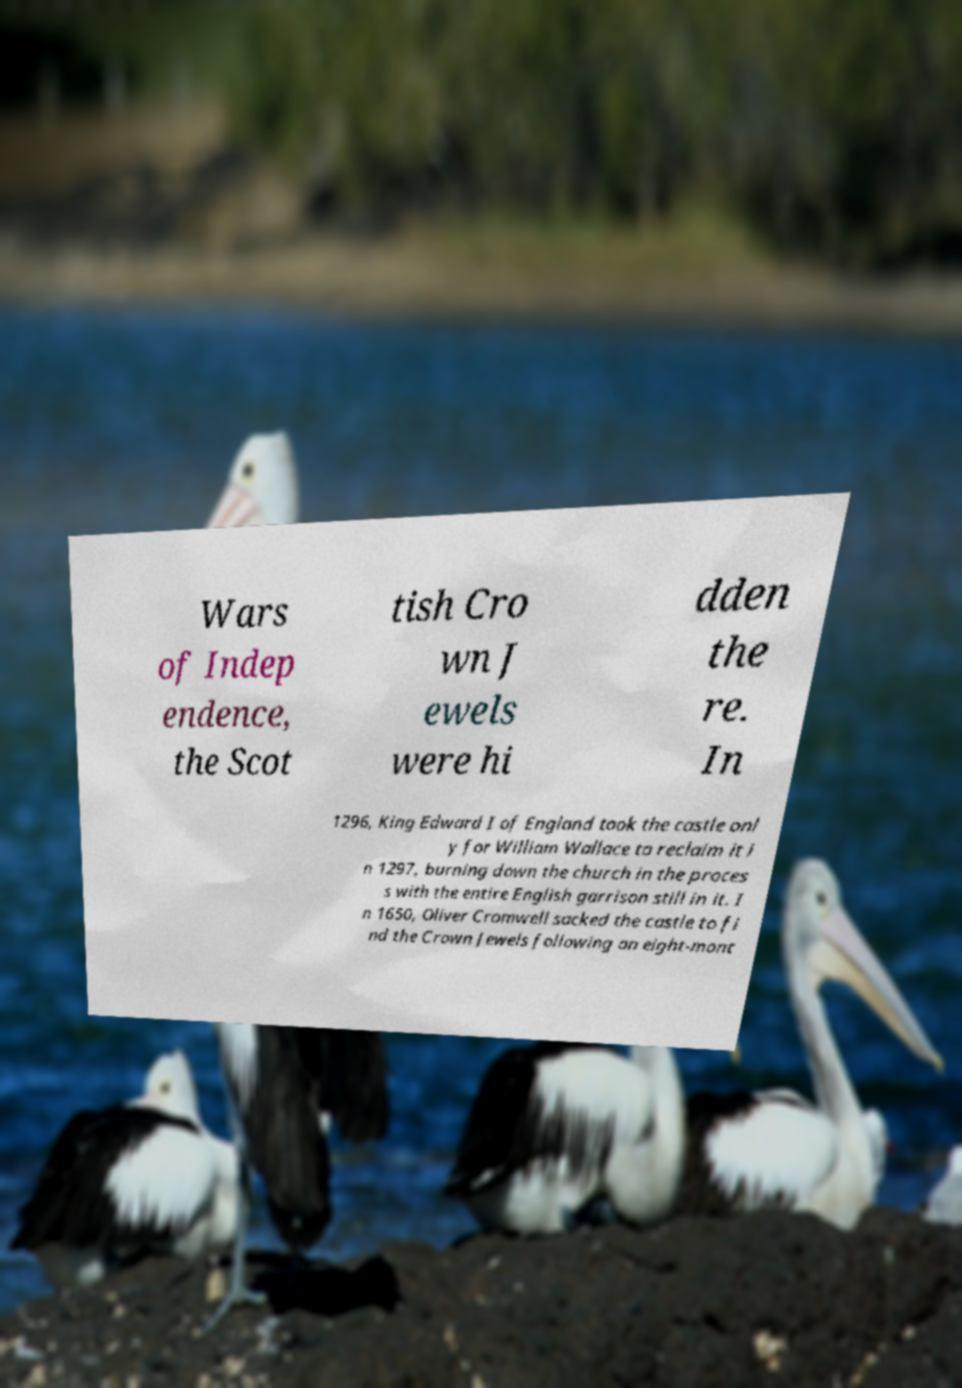Can you accurately transcribe the text from the provided image for me? Wars of Indep endence, the Scot tish Cro wn J ewels were hi dden the re. In 1296, King Edward I of England took the castle onl y for William Wallace to reclaim it i n 1297, burning down the church in the proces s with the entire English garrison still in it. I n 1650, Oliver Cromwell sacked the castle to fi nd the Crown Jewels following an eight-mont 